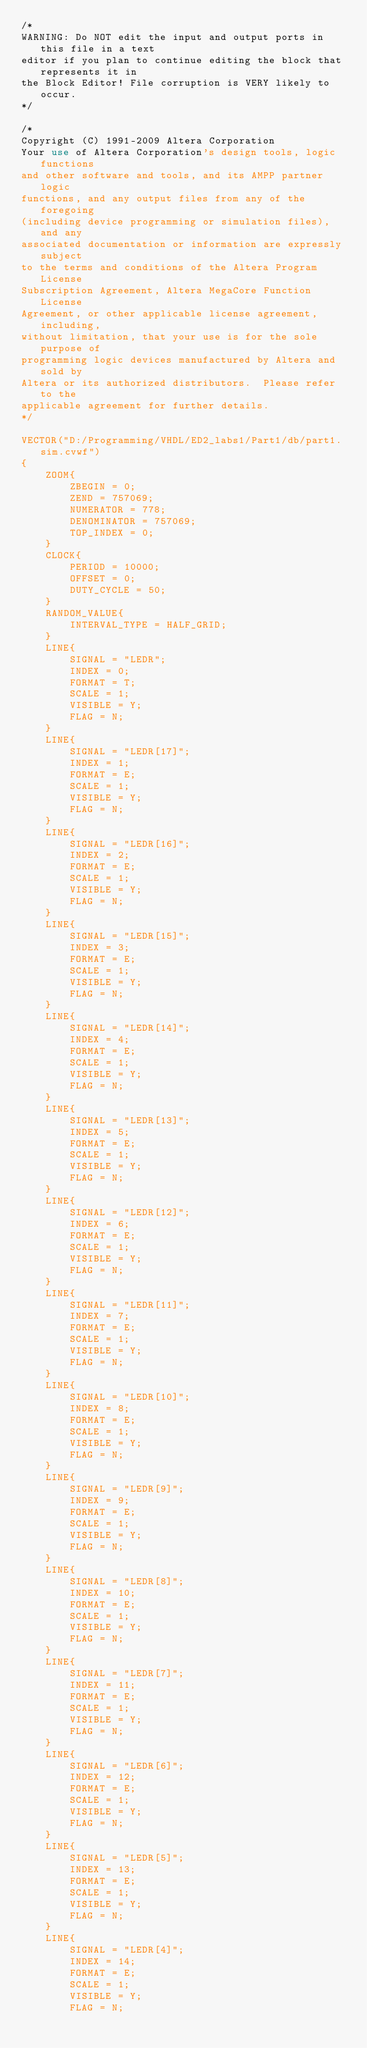<code> <loc_0><loc_0><loc_500><loc_500><_XML_>/*
WARNING: Do NOT edit the input and output ports in this file in a text
editor if you plan to continue editing the block that represents it in
the Block Editor! File corruption is VERY likely to occur.
*/

/*
Copyright (C) 1991-2009 Altera Corporation
Your use of Altera Corporation's design tools, logic functions 
and other software and tools, and its AMPP partner logic 
functions, and any output files from any of the foregoing 
(including device programming or simulation files), and any 
associated documentation or information are expressly subject 
to the terms and conditions of the Altera Program License 
Subscription Agreement, Altera MegaCore Function License 
Agreement, or other applicable license agreement, including, 
without limitation, that your use is for the sole purpose of 
programming logic devices manufactured by Altera and sold by 
Altera or its authorized distributors.  Please refer to the 
applicable agreement for further details.
*/

VECTOR("D:/Programming/VHDL/ED2_labs1/Part1/db/part1.sim.cvwf")
{
	ZOOM{
		ZBEGIN = 0;
		ZEND = 757069;
		NUMERATOR = 778;
		DENOMINATOR = 757069;
		TOP_INDEX = 0;
	}
	CLOCK{
		PERIOD = 10000;
		OFFSET = 0;
		DUTY_CYCLE = 50;
	}
	RANDOM_VALUE{
		INTERVAL_TYPE = HALF_GRID;
	}
	LINE{
		SIGNAL = "LEDR";
		INDEX = 0;
		FORMAT = T;
		SCALE = 1;
		VISIBLE = Y;
		FLAG = N;
	}
	LINE{
		SIGNAL = "LEDR[17]";
		INDEX = 1;
		FORMAT = E;
		SCALE = 1;
		VISIBLE = Y;
		FLAG = N;
	}
	LINE{
		SIGNAL = "LEDR[16]";
		INDEX = 2;
		FORMAT = E;
		SCALE = 1;
		VISIBLE = Y;
		FLAG = N;
	}
	LINE{
		SIGNAL = "LEDR[15]";
		INDEX = 3;
		FORMAT = E;
		SCALE = 1;
		VISIBLE = Y;
		FLAG = N;
	}
	LINE{
		SIGNAL = "LEDR[14]";
		INDEX = 4;
		FORMAT = E;
		SCALE = 1;
		VISIBLE = Y;
		FLAG = N;
	}
	LINE{
		SIGNAL = "LEDR[13]";
		INDEX = 5;
		FORMAT = E;
		SCALE = 1;
		VISIBLE = Y;
		FLAG = N;
	}
	LINE{
		SIGNAL = "LEDR[12]";
		INDEX = 6;
		FORMAT = E;
		SCALE = 1;
		VISIBLE = Y;
		FLAG = N;
	}
	LINE{
		SIGNAL = "LEDR[11]";
		INDEX = 7;
		FORMAT = E;
		SCALE = 1;
		VISIBLE = Y;
		FLAG = N;
	}
	LINE{
		SIGNAL = "LEDR[10]";
		INDEX = 8;
		FORMAT = E;
		SCALE = 1;
		VISIBLE = Y;
		FLAG = N;
	}
	LINE{
		SIGNAL = "LEDR[9]";
		INDEX = 9;
		FORMAT = E;
		SCALE = 1;
		VISIBLE = Y;
		FLAG = N;
	}
	LINE{
		SIGNAL = "LEDR[8]";
		INDEX = 10;
		FORMAT = E;
		SCALE = 1;
		VISIBLE = Y;
		FLAG = N;
	}
	LINE{
		SIGNAL = "LEDR[7]";
		INDEX = 11;
		FORMAT = E;
		SCALE = 1;
		VISIBLE = Y;
		FLAG = N;
	}
	LINE{
		SIGNAL = "LEDR[6]";
		INDEX = 12;
		FORMAT = E;
		SCALE = 1;
		VISIBLE = Y;
		FLAG = N;
	}
	LINE{
		SIGNAL = "LEDR[5]";
		INDEX = 13;
		FORMAT = E;
		SCALE = 1;
		VISIBLE = Y;
		FLAG = N;
	}
	LINE{
		SIGNAL = "LEDR[4]";
		INDEX = 14;
		FORMAT = E;
		SCALE = 1;
		VISIBLE = Y;
		FLAG = N;</code> 